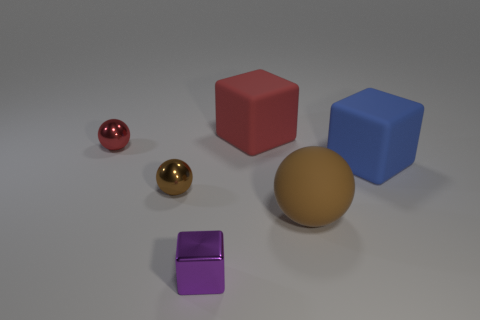How many rubber things are either cyan balls or tiny spheres?
Keep it short and to the point. 0. Are there any big gray cylinders that have the same material as the large blue object?
Provide a short and direct response. No. How many brown objects are both on the left side of the brown rubber sphere and to the right of the tiny purple metal cube?
Provide a short and direct response. 0. Is the number of large red matte things in front of the big red matte object less than the number of small red spheres that are behind the brown metal ball?
Make the answer very short. Yes. Do the tiny red thing and the small brown object have the same shape?
Offer a very short reply. Yes. How many other objects are the same size as the red matte block?
Your answer should be very brief. 2. How many objects are rubber objects in front of the large red object or objects to the left of the large brown rubber ball?
Your answer should be compact. 6. How many small red objects are the same shape as the blue rubber object?
Provide a short and direct response. 0. The cube that is both left of the blue rubber cube and behind the shiny cube is made of what material?
Make the answer very short. Rubber. There is a blue matte object; what number of small objects are behind it?
Make the answer very short. 1. 